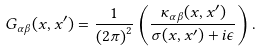<formula> <loc_0><loc_0><loc_500><loc_500>G _ { \alpha \beta } ( x , x ^ { \prime } ) = \frac { 1 } { \left ( 2 \pi \right ) ^ { 2 } } \left ( \frac { \kappa _ { \alpha \beta } ( x , x ^ { \prime } ) } { \sigma ( x , x ^ { \prime } ) + i \epsilon } \right ) .</formula> 